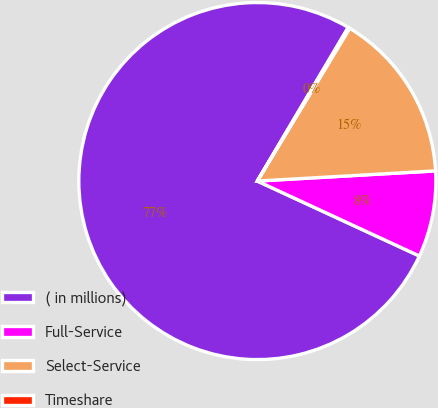<chart> <loc_0><loc_0><loc_500><loc_500><pie_chart><fcel>( in millions)<fcel>Full-Service<fcel>Select-Service<fcel>Timeshare<nl><fcel>76.61%<fcel>7.8%<fcel>15.44%<fcel>0.15%<nl></chart> 